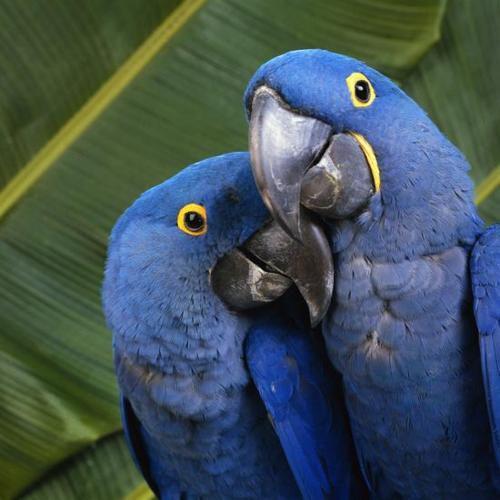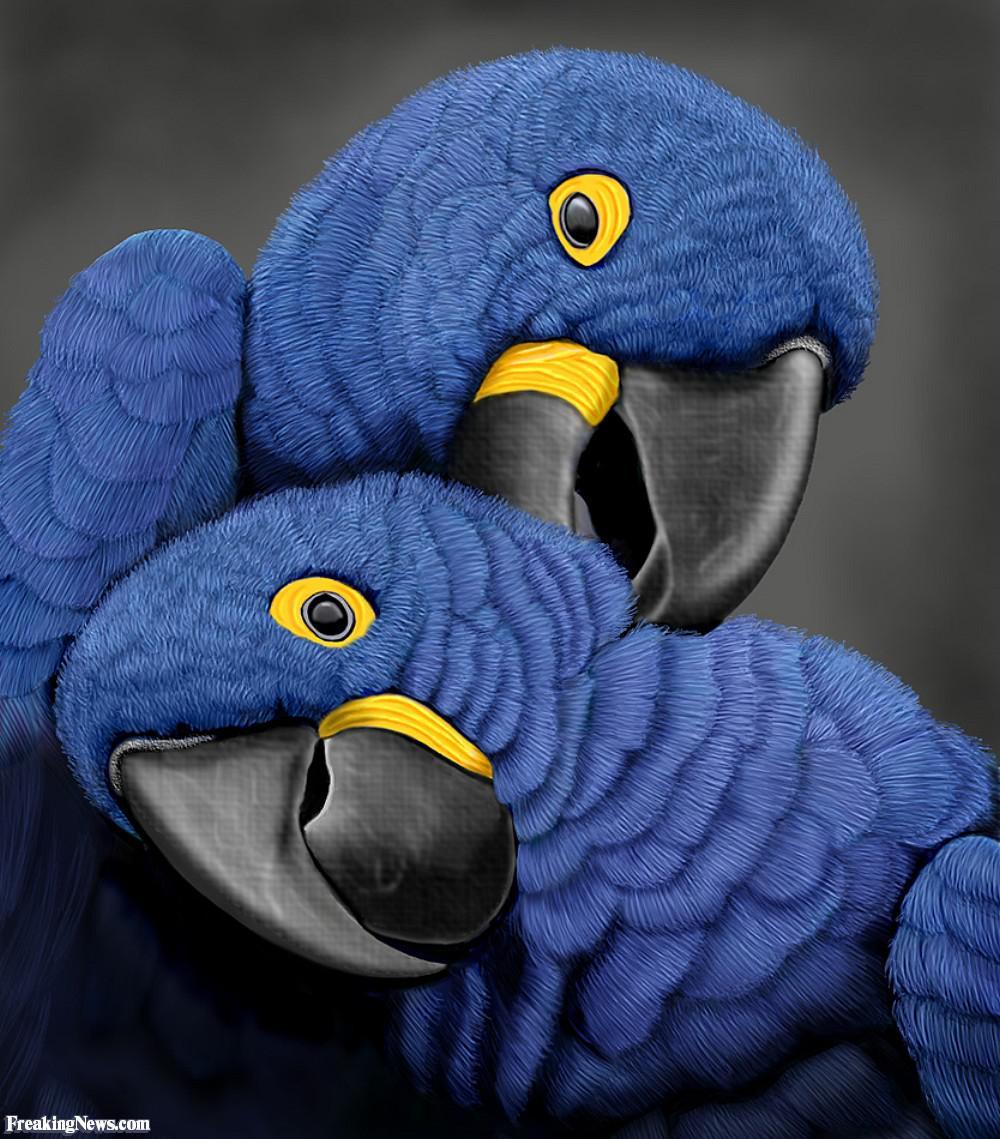The first image is the image on the left, the second image is the image on the right. Assess this claim about the two images: "There are two birds in the image on the right.". Correct or not? Answer yes or no. Yes. 